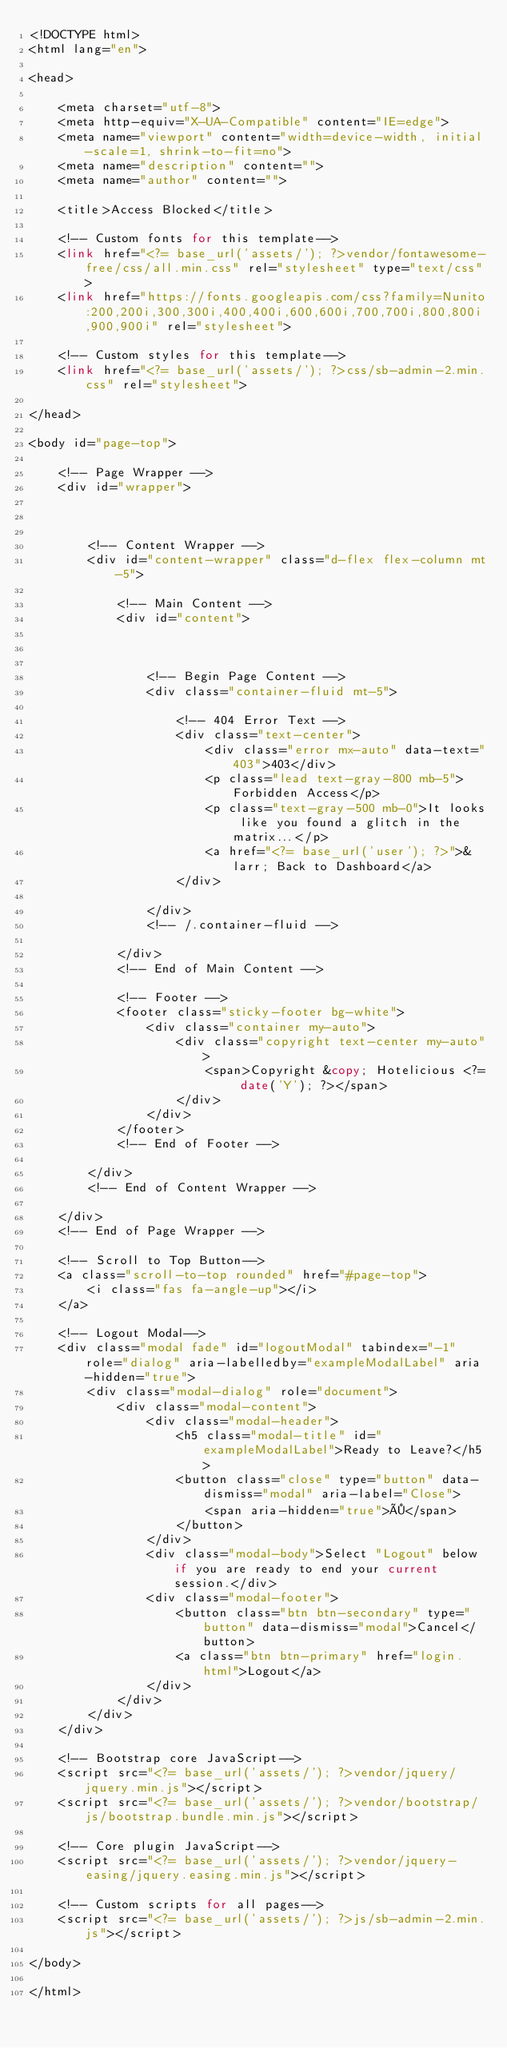Convert code to text. <code><loc_0><loc_0><loc_500><loc_500><_PHP_><!DOCTYPE html>
<html lang="en">

<head>

    <meta charset="utf-8">
    <meta http-equiv="X-UA-Compatible" content="IE=edge">
    <meta name="viewport" content="width=device-width, initial-scale=1, shrink-to-fit=no">
    <meta name="description" content="">
    <meta name="author" content="">

    <title>Access Blocked</title>

    <!-- Custom fonts for this template-->
    <link href="<?= base_url('assets/'); ?>vendor/fontawesome-free/css/all.min.css" rel="stylesheet" type="text/css">
    <link href="https://fonts.googleapis.com/css?family=Nunito:200,200i,300,300i,400,400i,600,600i,700,700i,800,800i,900,900i" rel="stylesheet">

    <!-- Custom styles for this template-->
    <link href="<?= base_url('assets/'); ?>css/sb-admin-2.min.css" rel="stylesheet">

</head>

<body id="page-top">

    <!-- Page Wrapper -->
    <div id="wrapper">



        <!-- Content Wrapper -->
        <div id="content-wrapper" class="d-flex flex-column mt-5">

            <!-- Main Content -->
            <div id="content">



                <!-- Begin Page Content -->
                <div class="container-fluid mt-5">

                    <!-- 404 Error Text -->
                    <div class="text-center">
                        <div class="error mx-auto" data-text="403">403</div>
                        <p class="lead text-gray-800 mb-5">Forbidden Access</p>
                        <p class="text-gray-500 mb-0">It looks like you found a glitch in the matrix...</p>
                        <a href="<?= base_url('user'); ?>">&larr; Back to Dashboard</a>
                    </div>

                </div>
                <!-- /.container-fluid -->

            </div>
            <!-- End of Main Content -->

            <!-- Footer -->
            <footer class="sticky-footer bg-white">
                <div class="container my-auto">
                    <div class="copyright text-center my-auto">
                        <span>Copyright &copy; Hotelicious <?= date('Y'); ?></span>
                    </div>
                </div>
            </footer>
            <!-- End of Footer -->

        </div>
        <!-- End of Content Wrapper -->

    </div>
    <!-- End of Page Wrapper -->

    <!-- Scroll to Top Button-->
    <a class="scroll-to-top rounded" href="#page-top">
        <i class="fas fa-angle-up"></i>
    </a>

    <!-- Logout Modal-->
    <div class="modal fade" id="logoutModal" tabindex="-1" role="dialog" aria-labelledby="exampleModalLabel" aria-hidden="true">
        <div class="modal-dialog" role="document">
            <div class="modal-content">
                <div class="modal-header">
                    <h5 class="modal-title" id="exampleModalLabel">Ready to Leave?</h5>
                    <button class="close" type="button" data-dismiss="modal" aria-label="Close">
                        <span aria-hidden="true">×</span>
                    </button>
                </div>
                <div class="modal-body">Select "Logout" below if you are ready to end your current session.</div>
                <div class="modal-footer">
                    <button class="btn btn-secondary" type="button" data-dismiss="modal">Cancel</button>
                    <a class="btn btn-primary" href="login.html">Logout</a>
                </div>
            </div>
        </div>
    </div>

    <!-- Bootstrap core JavaScript-->
    <script src="<?= base_url('assets/'); ?>vendor/jquery/jquery.min.js"></script>
    <script src="<?= base_url('assets/'); ?>vendor/bootstrap/js/bootstrap.bundle.min.js"></script>

    <!-- Core plugin JavaScript-->
    <script src="<?= base_url('assets/'); ?>vendor/jquery-easing/jquery.easing.min.js"></script>

    <!-- Custom scripts for all pages-->
    <script src="<?= base_url('assets/'); ?>js/sb-admin-2.min.js"></script>

</body>

</html></code> 